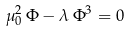<formula> <loc_0><loc_0><loc_500><loc_500>\mu _ { 0 } ^ { 2 } \, \Phi - \lambda \, \Phi ^ { 3 } = 0</formula> 